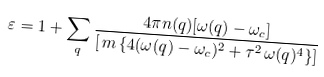<formula> <loc_0><loc_0><loc_500><loc_500>\varepsilon = 1 + \sum _ { q } \frac { 4 \pi n ( q ) [ \omega ( q ) - \omega _ { c } ] } { \left [ \, m \, \{ 4 ( \omega ( q ) - \omega _ { c } ) ^ { 2 } + \tau ^ { 2 } \, \omega ( q ) ^ { 4 } \} \right ] }</formula> 